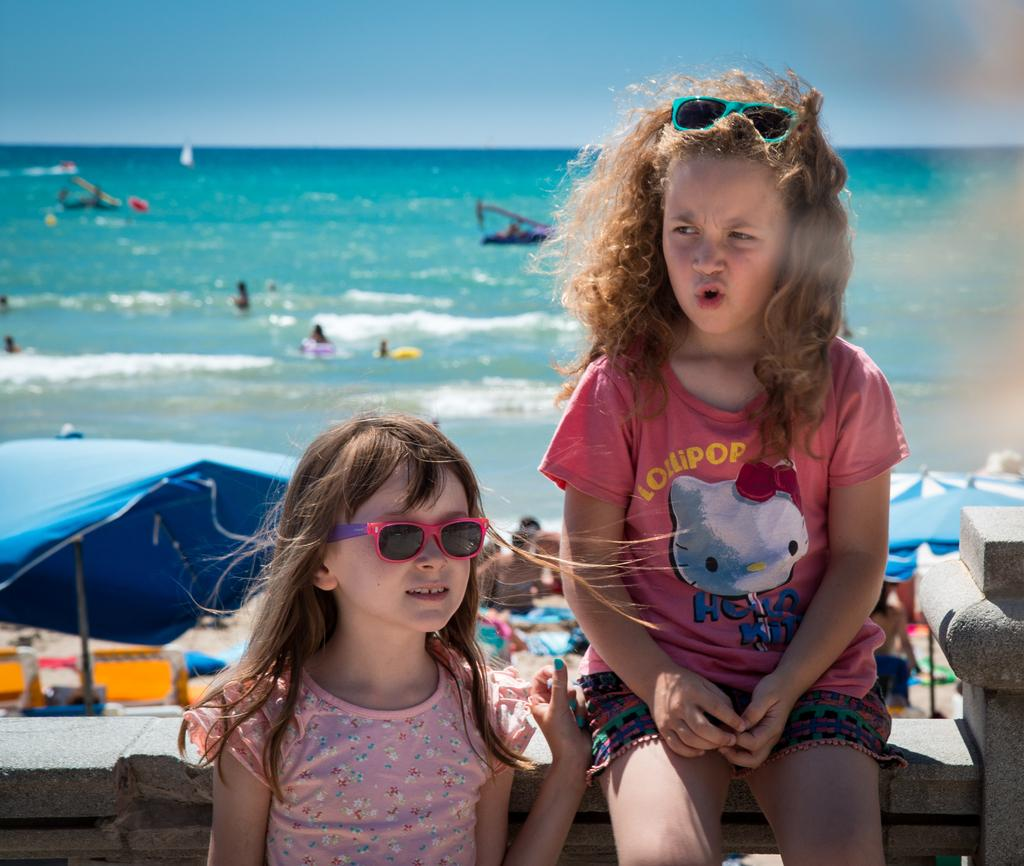Who or what can be seen in the image? There are people in the image. What is the primary setting or environment in the image? There is water visible in the image. What type of shelter is present in the image? There is a tent in the image. What is visible above the people and the tent in the image? The sky is visible in the image. What type of bun is being served at the committee meeting in the image? There is no committee meeting or bun present in the image. Can you tell me how many bees are buzzing around the people in the image? There are no bees visible in the image. 